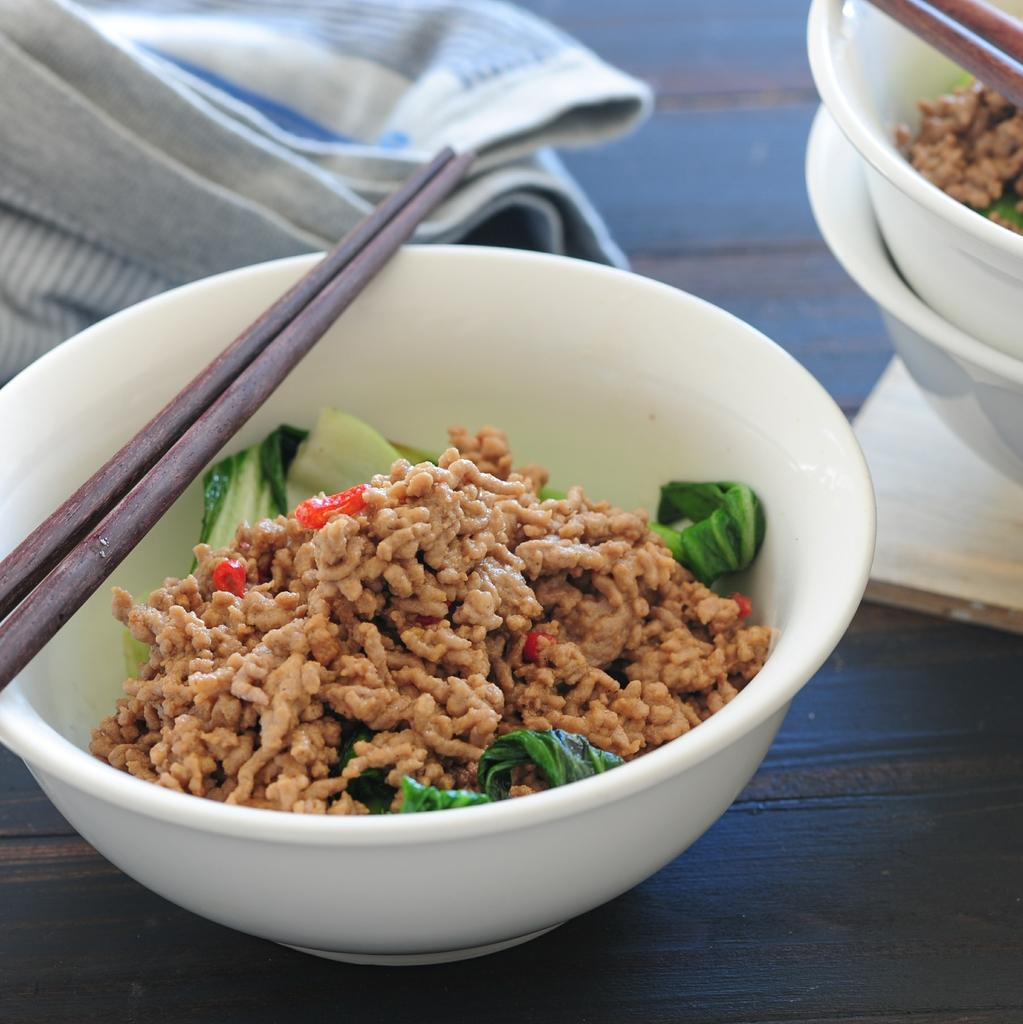What is in the bowls that are visible in the image? There are food items in the bowls. What utensils are placed on top of the bowls? Chopsticks are placed on top of the bowls. What type of material is covering the table? There is a cloth on the table. What type of horse can be seen in the image? There is no horse present in the image. Is there a boat visible in the image? There is no boat present in the image. 